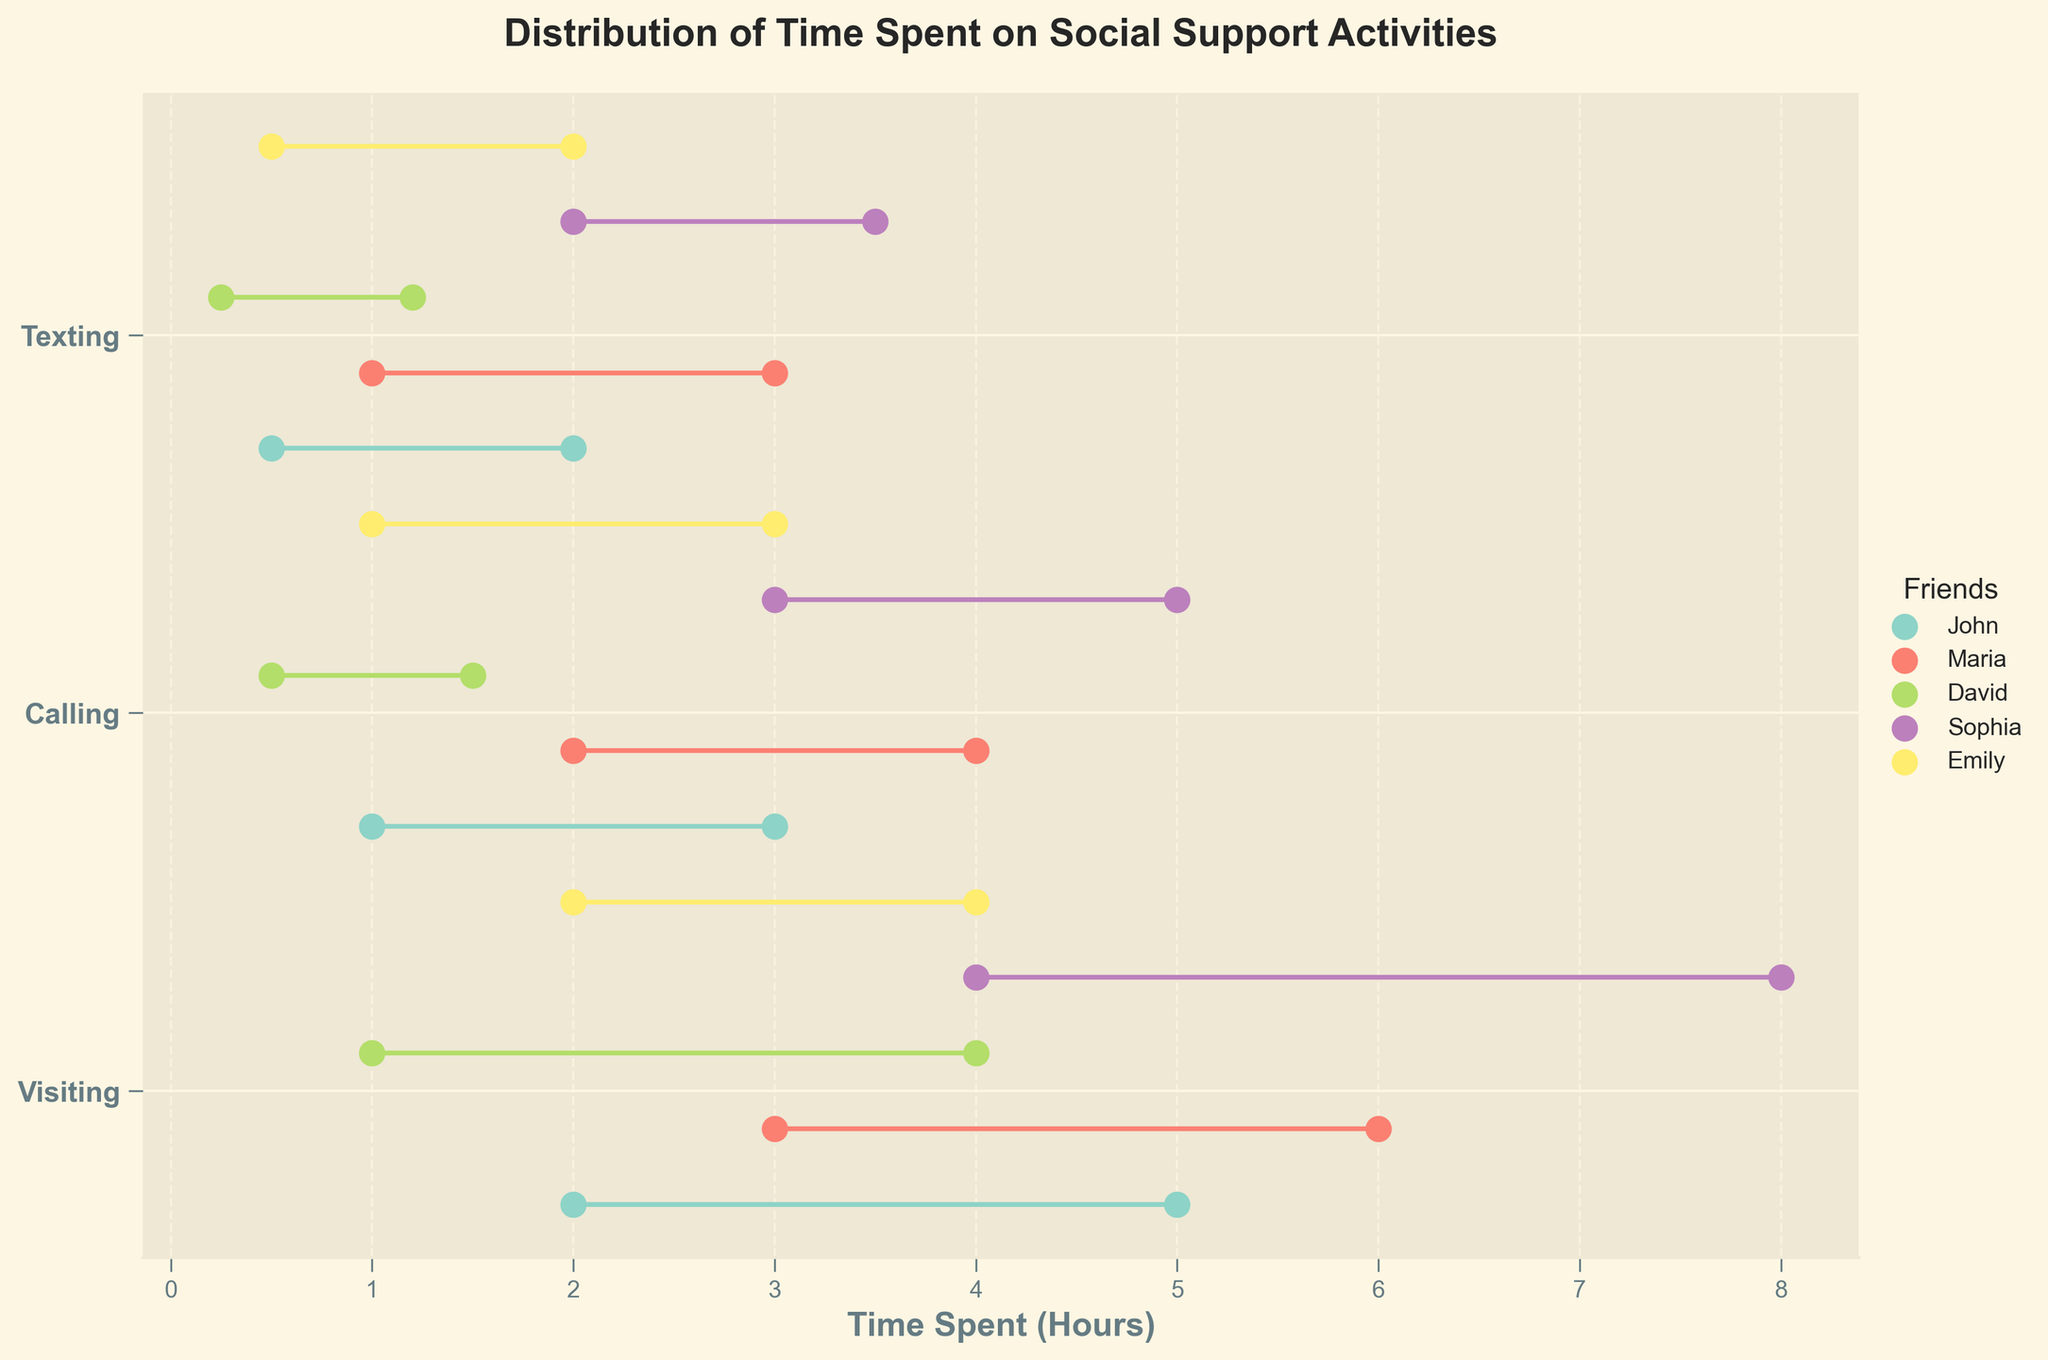What's the title of the plot? The title of the plot is usually displayed at the top and is meant to give an idea of what the plot is about. In this case, the title reads "Distribution of Time Spent on Social Support Activities".
Answer: Distribution of Time Spent on Social Support Activities How many different friends are represented in the plot? The plot includes a legend titled "Friends" which lists all the names represented. By counting these names, we can see there are five different friends: John, Maria, David, Sophia, and Emily.
Answer: 5 Which activity does Sophia spend the most time on? By locating Sophia’s data points and analyzing the range for each activity, you can see the highest maximum value. For Sophia, this highest value is for Visiting, which spans from 4 to 8 hours.
Answer: Visiting What is the minimum time David spends on calling? To find this, locate David’s data points for the activity "Calling". The minimum time spent by David on calling is indicated directly by the leftmost dot in his range, which is 0.5 hours.
Answer: 0.5 hours What is the range of time spent by Emily on visiting? Observe the range of dots for the activity "Visiting" and Emily’s data points. The range of time Emily spends on visiting is from 2 to 4 hours.
Answer: 2 to 4 hours Which friend has the smallest range of time spent on any activity? Comparing the length of the ranges for all friends across all activities, David’s time spent on Calling (0.5 to 1.5, range of 1 hour) is the smallest.
Answer: David Which activity has the most consistent maximum time across all friends? Analyze the maximum times for each activity across all friends. Texting has the most consistent maximum time (ranging from 1.2 to 3.5), compared to the wider ranges in Visiting and Calling.
Answer: Texting What is the average of the maximum time spent by all friends on calling? Add the maximum times for Calling across all friends (3 + 4 + 1.5 + 5 + 3) and divide by 5: (3 + 4 + 1.5 + 5 + 3) / 5 = 3.3 hours.
Answer: 3.3 hours 